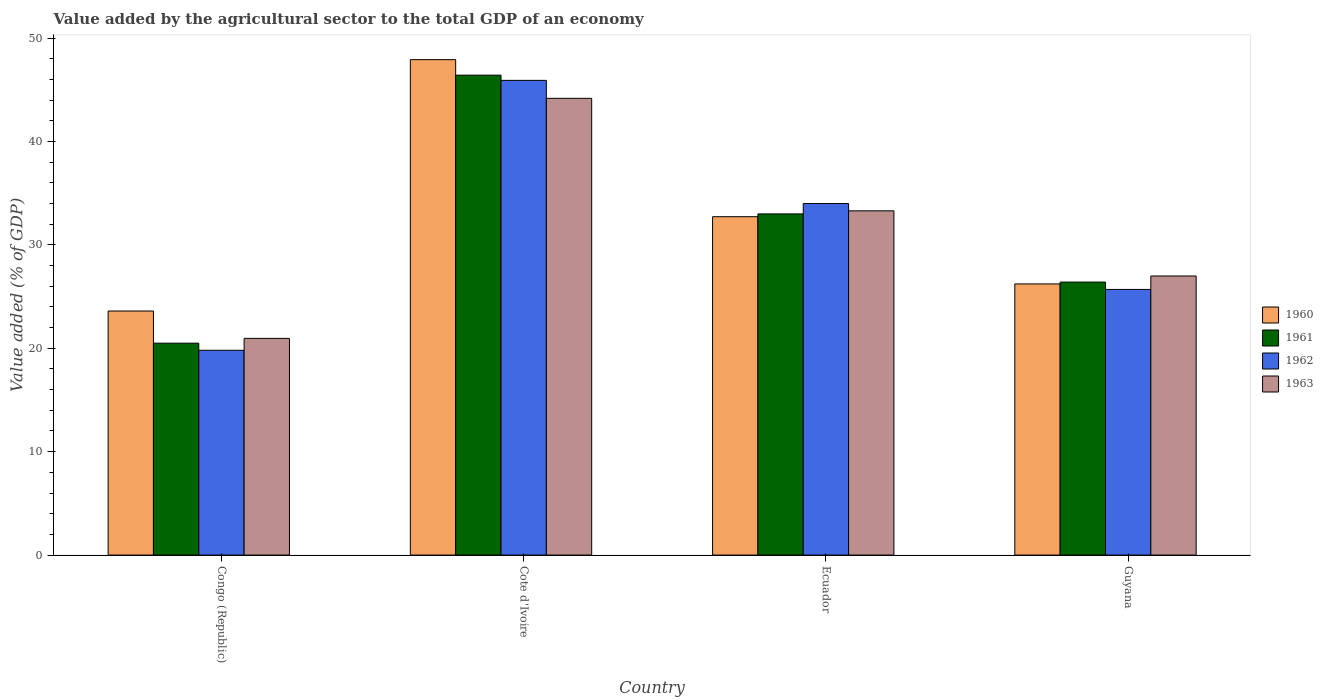How many groups of bars are there?
Keep it short and to the point. 4. What is the label of the 2nd group of bars from the left?
Offer a terse response. Cote d'Ivoire. What is the value added by the agricultural sector to the total GDP in 1963 in Ecuador?
Offer a terse response. 33.29. Across all countries, what is the maximum value added by the agricultural sector to the total GDP in 1963?
Give a very brief answer. 44.17. Across all countries, what is the minimum value added by the agricultural sector to the total GDP in 1963?
Offer a terse response. 20.95. In which country was the value added by the agricultural sector to the total GDP in 1962 maximum?
Give a very brief answer. Cote d'Ivoire. In which country was the value added by the agricultural sector to the total GDP in 1960 minimum?
Your answer should be compact. Congo (Republic). What is the total value added by the agricultural sector to the total GDP in 1963 in the graph?
Keep it short and to the point. 125.4. What is the difference between the value added by the agricultural sector to the total GDP in 1961 in Congo (Republic) and that in Ecuador?
Your answer should be very brief. -12.5. What is the difference between the value added by the agricultural sector to the total GDP in 1963 in Congo (Republic) and the value added by the agricultural sector to the total GDP in 1961 in Ecuador?
Give a very brief answer. -12.04. What is the average value added by the agricultural sector to the total GDP in 1960 per country?
Your answer should be compact. 32.61. What is the difference between the value added by the agricultural sector to the total GDP of/in 1960 and value added by the agricultural sector to the total GDP of/in 1962 in Congo (Republic)?
Provide a succinct answer. 3.8. What is the ratio of the value added by the agricultural sector to the total GDP in 1961 in Ecuador to that in Guyana?
Offer a terse response. 1.25. Is the value added by the agricultural sector to the total GDP in 1962 in Ecuador less than that in Guyana?
Provide a short and direct response. No. Is the difference between the value added by the agricultural sector to the total GDP in 1960 in Congo (Republic) and Guyana greater than the difference between the value added by the agricultural sector to the total GDP in 1962 in Congo (Republic) and Guyana?
Your response must be concise. Yes. What is the difference between the highest and the second highest value added by the agricultural sector to the total GDP in 1963?
Give a very brief answer. 6.3. What is the difference between the highest and the lowest value added by the agricultural sector to the total GDP in 1960?
Your response must be concise. 24.31. What does the 4th bar from the left in Ecuador represents?
Your answer should be very brief. 1963. What does the 3rd bar from the right in Ecuador represents?
Make the answer very short. 1961. Is it the case that in every country, the sum of the value added by the agricultural sector to the total GDP in 1963 and value added by the agricultural sector to the total GDP in 1960 is greater than the value added by the agricultural sector to the total GDP in 1962?
Offer a terse response. Yes. How many bars are there?
Keep it short and to the point. 16. Does the graph contain grids?
Your answer should be compact. No. How many legend labels are there?
Your answer should be very brief. 4. How are the legend labels stacked?
Provide a succinct answer. Vertical. What is the title of the graph?
Keep it short and to the point. Value added by the agricultural sector to the total GDP of an economy. Does "1962" appear as one of the legend labels in the graph?
Make the answer very short. Yes. What is the label or title of the Y-axis?
Give a very brief answer. Value added (% of GDP). What is the Value added (% of GDP) in 1960 in Congo (Republic)?
Make the answer very short. 23.6. What is the Value added (% of GDP) in 1961 in Congo (Republic)?
Provide a succinct answer. 20.49. What is the Value added (% of GDP) of 1962 in Congo (Republic)?
Keep it short and to the point. 19.8. What is the Value added (% of GDP) of 1963 in Congo (Republic)?
Keep it short and to the point. 20.95. What is the Value added (% of GDP) of 1960 in Cote d'Ivoire?
Provide a succinct answer. 47.91. What is the Value added (% of GDP) of 1961 in Cote d'Ivoire?
Keep it short and to the point. 46.41. What is the Value added (% of GDP) in 1962 in Cote d'Ivoire?
Provide a succinct answer. 45.9. What is the Value added (% of GDP) in 1963 in Cote d'Ivoire?
Make the answer very short. 44.17. What is the Value added (% of GDP) of 1960 in Ecuador?
Offer a very short reply. 32.72. What is the Value added (% of GDP) of 1961 in Ecuador?
Provide a short and direct response. 32.99. What is the Value added (% of GDP) of 1962 in Ecuador?
Your answer should be compact. 33.99. What is the Value added (% of GDP) in 1963 in Ecuador?
Your response must be concise. 33.29. What is the Value added (% of GDP) of 1960 in Guyana?
Offer a very short reply. 26.22. What is the Value added (% of GDP) in 1961 in Guyana?
Your answer should be very brief. 26.4. What is the Value added (% of GDP) in 1962 in Guyana?
Offer a very short reply. 25.69. What is the Value added (% of GDP) of 1963 in Guyana?
Give a very brief answer. 26.99. Across all countries, what is the maximum Value added (% of GDP) of 1960?
Offer a very short reply. 47.91. Across all countries, what is the maximum Value added (% of GDP) of 1961?
Provide a succinct answer. 46.41. Across all countries, what is the maximum Value added (% of GDP) in 1962?
Provide a succinct answer. 45.9. Across all countries, what is the maximum Value added (% of GDP) of 1963?
Offer a very short reply. 44.17. Across all countries, what is the minimum Value added (% of GDP) of 1960?
Your answer should be compact. 23.6. Across all countries, what is the minimum Value added (% of GDP) of 1961?
Keep it short and to the point. 20.49. Across all countries, what is the minimum Value added (% of GDP) of 1962?
Keep it short and to the point. 19.8. Across all countries, what is the minimum Value added (% of GDP) in 1963?
Your answer should be compact. 20.95. What is the total Value added (% of GDP) of 1960 in the graph?
Keep it short and to the point. 130.45. What is the total Value added (% of GDP) of 1961 in the graph?
Your answer should be very brief. 126.29. What is the total Value added (% of GDP) in 1962 in the graph?
Your answer should be compact. 125.39. What is the total Value added (% of GDP) in 1963 in the graph?
Your answer should be compact. 125.4. What is the difference between the Value added (% of GDP) of 1960 in Congo (Republic) and that in Cote d'Ivoire?
Your answer should be compact. -24.31. What is the difference between the Value added (% of GDP) of 1961 in Congo (Republic) and that in Cote d'Ivoire?
Provide a short and direct response. -25.91. What is the difference between the Value added (% of GDP) in 1962 in Congo (Republic) and that in Cote d'Ivoire?
Provide a succinct answer. -26.1. What is the difference between the Value added (% of GDP) of 1963 in Congo (Republic) and that in Cote d'Ivoire?
Keep it short and to the point. -23.21. What is the difference between the Value added (% of GDP) in 1960 in Congo (Republic) and that in Ecuador?
Keep it short and to the point. -9.12. What is the difference between the Value added (% of GDP) of 1961 in Congo (Republic) and that in Ecuador?
Make the answer very short. -12.5. What is the difference between the Value added (% of GDP) in 1962 in Congo (Republic) and that in Ecuador?
Your answer should be compact. -14.19. What is the difference between the Value added (% of GDP) of 1963 in Congo (Republic) and that in Ecuador?
Provide a short and direct response. -12.33. What is the difference between the Value added (% of GDP) in 1960 in Congo (Republic) and that in Guyana?
Give a very brief answer. -2.62. What is the difference between the Value added (% of GDP) of 1961 in Congo (Republic) and that in Guyana?
Offer a very short reply. -5.91. What is the difference between the Value added (% of GDP) in 1962 in Congo (Republic) and that in Guyana?
Keep it short and to the point. -5.88. What is the difference between the Value added (% of GDP) of 1963 in Congo (Republic) and that in Guyana?
Your response must be concise. -6.03. What is the difference between the Value added (% of GDP) of 1960 in Cote d'Ivoire and that in Ecuador?
Offer a terse response. 15.19. What is the difference between the Value added (% of GDP) in 1961 in Cote d'Ivoire and that in Ecuador?
Give a very brief answer. 13.42. What is the difference between the Value added (% of GDP) of 1962 in Cote d'Ivoire and that in Ecuador?
Ensure brevity in your answer.  11.91. What is the difference between the Value added (% of GDP) of 1963 in Cote d'Ivoire and that in Ecuador?
Provide a short and direct response. 10.88. What is the difference between the Value added (% of GDP) of 1960 in Cote d'Ivoire and that in Guyana?
Keep it short and to the point. 21.69. What is the difference between the Value added (% of GDP) in 1961 in Cote d'Ivoire and that in Guyana?
Give a very brief answer. 20.01. What is the difference between the Value added (% of GDP) in 1962 in Cote d'Ivoire and that in Guyana?
Offer a terse response. 20.22. What is the difference between the Value added (% of GDP) in 1963 in Cote d'Ivoire and that in Guyana?
Your response must be concise. 17.18. What is the difference between the Value added (% of GDP) of 1960 in Ecuador and that in Guyana?
Your response must be concise. 6.5. What is the difference between the Value added (% of GDP) in 1961 in Ecuador and that in Guyana?
Give a very brief answer. 6.59. What is the difference between the Value added (% of GDP) in 1962 in Ecuador and that in Guyana?
Provide a succinct answer. 8.31. What is the difference between the Value added (% of GDP) in 1963 in Ecuador and that in Guyana?
Your response must be concise. 6.3. What is the difference between the Value added (% of GDP) of 1960 in Congo (Republic) and the Value added (% of GDP) of 1961 in Cote d'Ivoire?
Provide a short and direct response. -22.81. What is the difference between the Value added (% of GDP) of 1960 in Congo (Republic) and the Value added (% of GDP) of 1962 in Cote d'Ivoire?
Your answer should be compact. -22.3. What is the difference between the Value added (% of GDP) in 1960 in Congo (Republic) and the Value added (% of GDP) in 1963 in Cote d'Ivoire?
Offer a very short reply. -20.57. What is the difference between the Value added (% of GDP) of 1961 in Congo (Republic) and the Value added (% of GDP) of 1962 in Cote d'Ivoire?
Offer a very short reply. -25.41. What is the difference between the Value added (% of GDP) of 1961 in Congo (Republic) and the Value added (% of GDP) of 1963 in Cote d'Ivoire?
Provide a short and direct response. -23.68. What is the difference between the Value added (% of GDP) in 1962 in Congo (Republic) and the Value added (% of GDP) in 1963 in Cote d'Ivoire?
Your answer should be very brief. -24.36. What is the difference between the Value added (% of GDP) of 1960 in Congo (Republic) and the Value added (% of GDP) of 1961 in Ecuador?
Your answer should be very brief. -9.39. What is the difference between the Value added (% of GDP) of 1960 in Congo (Republic) and the Value added (% of GDP) of 1962 in Ecuador?
Your answer should be very brief. -10.39. What is the difference between the Value added (% of GDP) in 1960 in Congo (Republic) and the Value added (% of GDP) in 1963 in Ecuador?
Give a very brief answer. -9.69. What is the difference between the Value added (% of GDP) in 1961 in Congo (Republic) and the Value added (% of GDP) in 1962 in Ecuador?
Provide a short and direct response. -13.5. What is the difference between the Value added (% of GDP) of 1961 in Congo (Republic) and the Value added (% of GDP) of 1963 in Ecuador?
Offer a very short reply. -12.8. What is the difference between the Value added (% of GDP) of 1962 in Congo (Republic) and the Value added (% of GDP) of 1963 in Ecuador?
Keep it short and to the point. -13.48. What is the difference between the Value added (% of GDP) in 1960 in Congo (Republic) and the Value added (% of GDP) in 1961 in Guyana?
Provide a succinct answer. -2.8. What is the difference between the Value added (% of GDP) in 1960 in Congo (Republic) and the Value added (% of GDP) in 1962 in Guyana?
Offer a very short reply. -2.09. What is the difference between the Value added (% of GDP) of 1960 in Congo (Republic) and the Value added (% of GDP) of 1963 in Guyana?
Keep it short and to the point. -3.39. What is the difference between the Value added (% of GDP) in 1961 in Congo (Republic) and the Value added (% of GDP) in 1962 in Guyana?
Your response must be concise. -5.2. What is the difference between the Value added (% of GDP) in 1961 in Congo (Republic) and the Value added (% of GDP) in 1963 in Guyana?
Provide a short and direct response. -6.49. What is the difference between the Value added (% of GDP) of 1962 in Congo (Republic) and the Value added (% of GDP) of 1963 in Guyana?
Your response must be concise. -7.18. What is the difference between the Value added (% of GDP) of 1960 in Cote d'Ivoire and the Value added (% of GDP) of 1961 in Ecuador?
Offer a very short reply. 14.92. What is the difference between the Value added (% of GDP) in 1960 in Cote d'Ivoire and the Value added (% of GDP) in 1962 in Ecuador?
Offer a terse response. 13.91. What is the difference between the Value added (% of GDP) in 1960 in Cote d'Ivoire and the Value added (% of GDP) in 1963 in Ecuador?
Offer a terse response. 14.62. What is the difference between the Value added (% of GDP) of 1961 in Cote d'Ivoire and the Value added (% of GDP) of 1962 in Ecuador?
Provide a succinct answer. 12.41. What is the difference between the Value added (% of GDP) of 1961 in Cote d'Ivoire and the Value added (% of GDP) of 1963 in Ecuador?
Offer a terse response. 13.12. What is the difference between the Value added (% of GDP) in 1962 in Cote d'Ivoire and the Value added (% of GDP) in 1963 in Ecuador?
Make the answer very short. 12.62. What is the difference between the Value added (% of GDP) of 1960 in Cote d'Ivoire and the Value added (% of GDP) of 1961 in Guyana?
Keep it short and to the point. 21.51. What is the difference between the Value added (% of GDP) in 1960 in Cote d'Ivoire and the Value added (% of GDP) in 1962 in Guyana?
Your answer should be very brief. 22.22. What is the difference between the Value added (% of GDP) of 1960 in Cote d'Ivoire and the Value added (% of GDP) of 1963 in Guyana?
Your answer should be compact. 20.92. What is the difference between the Value added (% of GDP) in 1961 in Cote d'Ivoire and the Value added (% of GDP) in 1962 in Guyana?
Ensure brevity in your answer.  20.72. What is the difference between the Value added (% of GDP) of 1961 in Cote d'Ivoire and the Value added (% of GDP) of 1963 in Guyana?
Your answer should be compact. 19.42. What is the difference between the Value added (% of GDP) in 1962 in Cote d'Ivoire and the Value added (% of GDP) in 1963 in Guyana?
Keep it short and to the point. 18.92. What is the difference between the Value added (% of GDP) of 1960 in Ecuador and the Value added (% of GDP) of 1961 in Guyana?
Give a very brief answer. 6.32. What is the difference between the Value added (% of GDP) in 1960 in Ecuador and the Value added (% of GDP) in 1962 in Guyana?
Offer a very short reply. 7.03. What is the difference between the Value added (% of GDP) of 1960 in Ecuador and the Value added (% of GDP) of 1963 in Guyana?
Your answer should be compact. 5.73. What is the difference between the Value added (% of GDP) of 1961 in Ecuador and the Value added (% of GDP) of 1962 in Guyana?
Offer a terse response. 7.3. What is the difference between the Value added (% of GDP) of 1961 in Ecuador and the Value added (% of GDP) of 1963 in Guyana?
Your response must be concise. 6. What is the difference between the Value added (% of GDP) of 1962 in Ecuador and the Value added (% of GDP) of 1963 in Guyana?
Ensure brevity in your answer.  7.01. What is the average Value added (% of GDP) in 1960 per country?
Offer a terse response. 32.61. What is the average Value added (% of GDP) of 1961 per country?
Provide a short and direct response. 31.57. What is the average Value added (% of GDP) of 1962 per country?
Your response must be concise. 31.35. What is the average Value added (% of GDP) in 1963 per country?
Provide a succinct answer. 31.35. What is the difference between the Value added (% of GDP) of 1960 and Value added (% of GDP) of 1961 in Congo (Republic)?
Offer a terse response. 3.11. What is the difference between the Value added (% of GDP) of 1960 and Value added (% of GDP) of 1962 in Congo (Republic)?
Offer a very short reply. 3.8. What is the difference between the Value added (% of GDP) of 1960 and Value added (% of GDP) of 1963 in Congo (Republic)?
Your answer should be compact. 2.65. What is the difference between the Value added (% of GDP) in 1961 and Value added (% of GDP) in 1962 in Congo (Republic)?
Keep it short and to the point. 0.69. What is the difference between the Value added (% of GDP) in 1961 and Value added (% of GDP) in 1963 in Congo (Republic)?
Provide a short and direct response. -0.46. What is the difference between the Value added (% of GDP) of 1962 and Value added (% of GDP) of 1963 in Congo (Republic)?
Keep it short and to the point. -1.15. What is the difference between the Value added (% of GDP) of 1960 and Value added (% of GDP) of 1961 in Cote d'Ivoire?
Your answer should be compact. 1.5. What is the difference between the Value added (% of GDP) of 1960 and Value added (% of GDP) of 1962 in Cote d'Ivoire?
Make the answer very short. 2. What is the difference between the Value added (% of GDP) in 1960 and Value added (% of GDP) in 1963 in Cote d'Ivoire?
Keep it short and to the point. 3.74. What is the difference between the Value added (% of GDP) in 1961 and Value added (% of GDP) in 1962 in Cote d'Ivoire?
Give a very brief answer. 0.5. What is the difference between the Value added (% of GDP) of 1961 and Value added (% of GDP) of 1963 in Cote d'Ivoire?
Your answer should be very brief. 2.24. What is the difference between the Value added (% of GDP) of 1962 and Value added (% of GDP) of 1963 in Cote d'Ivoire?
Give a very brief answer. 1.74. What is the difference between the Value added (% of GDP) in 1960 and Value added (% of GDP) in 1961 in Ecuador?
Give a very brief answer. -0.27. What is the difference between the Value added (% of GDP) of 1960 and Value added (% of GDP) of 1962 in Ecuador?
Offer a terse response. -1.27. What is the difference between the Value added (% of GDP) of 1960 and Value added (% of GDP) of 1963 in Ecuador?
Your answer should be very brief. -0.57. What is the difference between the Value added (% of GDP) of 1961 and Value added (% of GDP) of 1962 in Ecuador?
Keep it short and to the point. -1. What is the difference between the Value added (% of GDP) in 1961 and Value added (% of GDP) in 1963 in Ecuador?
Your answer should be compact. -0.3. What is the difference between the Value added (% of GDP) in 1962 and Value added (% of GDP) in 1963 in Ecuador?
Your answer should be compact. 0.71. What is the difference between the Value added (% of GDP) in 1960 and Value added (% of GDP) in 1961 in Guyana?
Provide a short and direct response. -0.18. What is the difference between the Value added (% of GDP) in 1960 and Value added (% of GDP) in 1962 in Guyana?
Keep it short and to the point. 0.53. What is the difference between the Value added (% of GDP) in 1960 and Value added (% of GDP) in 1963 in Guyana?
Your answer should be compact. -0.77. What is the difference between the Value added (% of GDP) of 1961 and Value added (% of GDP) of 1962 in Guyana?
Your answer should be very brief. 0.71. What is the difference between the Value added (% of GDP) in 1961 and Value added (% of GDP) in 1963 in Guyana?
Offer a terse response. -0.59. What is the difference between the Value added (% of GDP) in 1962 and Value added (% of GDP) in 1963 in Guyana?
Offer a terse response. -1.3. What is the ratio of the Value added (% of GDP) of 1960 in Congo (Republic) to that in Cote d'Ivoire?
Provide a succinct answer. 0.49. What is the ratio of the Value added (% of GDP) in 1961 in Congo (Republic) to that in Cote d'Ivoire?
Your answer should be very brief. 0.44. What is the ratio of the Value added (% of GDP) of 1962 in Congo (Republic) to that in Cote d'Ivoire?
Provide a short and direct response. 0.43. What is the ratio of the Value added (% of GDP) of 1963 in Congo (Republic) to that in Cote d'Ivoire?
Ensure brevity in your answer.  0.47. What is the ratio of the Value added (% of GDP) of 1960 in Congo (Republic) to that in Ecuador?
Your response must be concise. 0.72. What is the ratio of the Value added (% of GDP) in 1961 in Congo (Republic) to that in Ecuador?
Keep it short and to the point. 0.62. What is the ratio of the Value added (% of GDP) of 1962 in Congo (Republic) to that in Ecuador?
Make the answer very short. 0.58. What is the ratio of the Value added (% of GDP) of 1963 in Congo (Republic) to that in Ecuador?
Provide a short and direct response. 0.63. What is the ratio of the Value added (% of GDP) in 1960 in Congo (Republic) to that in Guyana?
Offer a very short reply. 0.9. What is the ratio of the Value added (% of GDP) of 1961 in Congo (Republic) to that in Guyana?
Provide a succinct answer. 0.78. What is the ratio of the Value added (% of GDP) of 1962 in Congo (Republic) to that in Guyana?
Offer a terse response. 0.77. What is the ratio of the Value added (% of GDP) in 1963 in Congo (Republic) to that in Guyana?
Make the answer very short. 0.78. What is the ratio of the Value added (% of GDP) of 1960 in Cote d'Ivoire to that in Ecuador?
Your answer should be compact. 1.46. What is the ratio of the Value added (% of GDP) of 1961 in Cote d'Ivoire to that in Ecuador?
Provide a short and direct response. 1.41. What is the ratio of the Value added (% of GDP) in 1962 in Cote d'Ivoire to that in Ecuador?
Make the answer very short. 1.35. What is the ratio of the Value added (% of GDP) in 1963 in Cote d'Ivoire to that in Ecuador?
Your answer should be compact. 1.33. What is the ratio of the Value added (% of GDP) in 1960 in Cote d'Ivoire to that in Guyana?
Provide a short and direct response. 1.83. What is the ratio of the Value added (% of GDP) in 1961 in Cote d'Ivoire to that in Guyana?
Keep it short and to the point. 1.76. What is the ratio of the Value added (% of GDP) in 1962 in Cote d'Ivoire to that in Guyana?
Offer a terse response. 1.79. What is the ratio of the Value added (% of GDP) in 1963 in Cote d'Ivoire to that in Guyana?
Your answer should be compact. 1.64. What is the ratio of the Value added (% of GDP) in 1960 in Ecuador to that in Guyana?
Make the answer very short. 1.25. What is the ratio of the Value added (% of GDP) of 1961 in Ecuador to that in Guyana?
Provide a succinct answer. 1.25. What is the ratio of the Value added (% of GDP) of 1962 in Ecuador to that in Guyana?
Provide a short and direct response. 1.32. What is the ratio of the Value added (% of GDP) of 1963 in Ecuador to that in Guyana?
Give a very brief answer. 1.23. What is the difference between the highest and the second highest Value added (% of GDP) of 1960?
Your answer should be compact. 15.19. What is the difference between the highest and the second highest Value added (% of GDP) in 1961?
Your response must be concise. 13.42. What is the difference between the highest and the second highest Value added (% of GDP) of 1962?
Your response must be concise. 11.91. What is the difference between the highest and the second highest Value added (% of GDP) of 1963?
Your answer should be very brief. 10.88. What is the difference between the highest and the lowest Value added (% of GDP) in 1960?
Give a very brief answer. 24.31. What is the difference between the highest and the lowest Value added (% of GDP) in 1961?
Offer a very short reply. 25.91. What is the difference between the highest and the lowest Value added (% of GDP) of 1962?
Provide a succinct answer. 26.1. What is the difference between the highest and the lowest Value added (% of GDP) in 1963?
Offer a terse response. 23.21. 